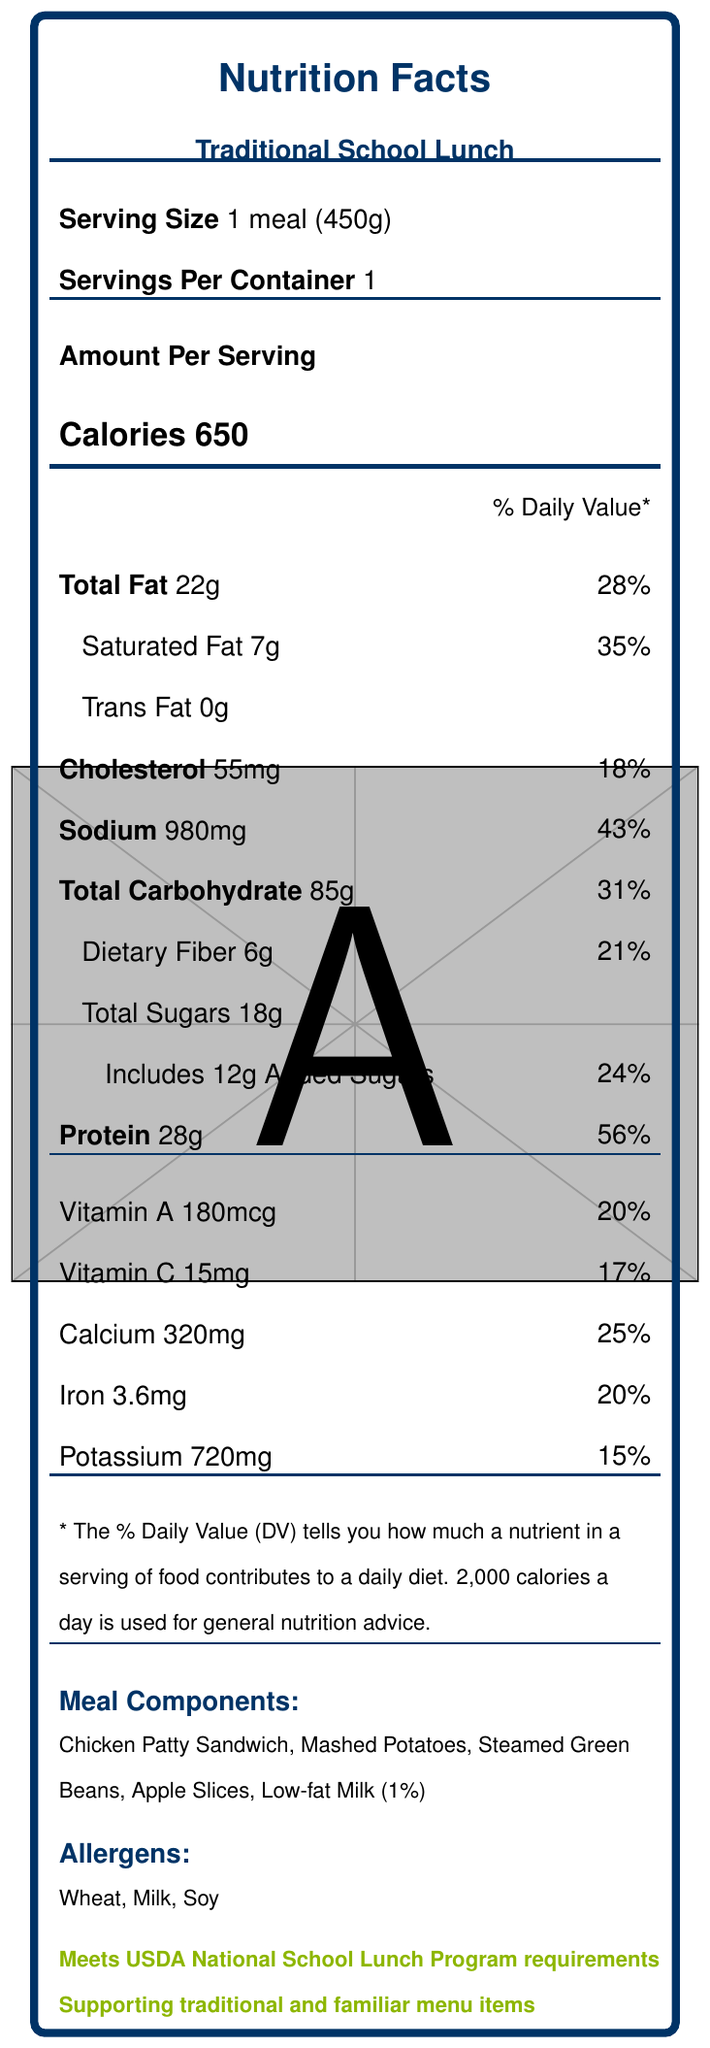What is the serving size for the school lunch meal? The serving size is explicitly stated as "1 meal (450g)" in the document.
Answer: 1 meal (450g) How many calories are in one serving of the meal? The number of calories per serving is listed as 650.
Answer: 650 What percentage of the daily value of saturated fat does the meal provide? The document states that the meal provides 7g of saturated fat, which is 35% of the daily value.
Answer: 35% How much sodium does the meal contain? The sodium content of the meal is specified as 980mg.
Answer: 980mg List the meal components included in the lunch. The meal components are listed in the document under "Meal Components".
Answer: Chicken Patty Sandwich, Mashed Potatoes, Steamed Green Beans, Apple Slices, Low-fat Milk (1%) What are the allergens present in the meal? The allergens are listed as "Wheat, Milk, Soy" in the "Allergens" section.
Answer: Wheat, Milk, Soy Which nutrient has the highest daily value percentage provided by the meal? A. Sodium B. Protein C. Vitamin A D. Calcium The meal provides 56% of the daily protein value, which is higher than the daily value percentage for sodium (43%), Vitamin A (20%), and calcium (25%).
Answer: B. Protein What is the primary source of protein in this meal? A. Apple Slices B. Low-fat Milk C. Chicken Patty Sandwich D. Steamed Green Beans The additional information section states that the source of protein is "Chicken patty made with whole muscle chicken".
Answer: C. Chicken Patty Sandwich Does the meal meet USDA National School Lunch Program requirements? The additional information section mentions that the meal "Meets USDA National School Lunch Program requirements".
Answer: Yes Summarize the main idea of the document. The document covers comprehensive nutritional data, meal components, allergens, and compliance notes for a traditional school lunch.
Answer: The document provides a detailed nutrition facts label for a standard school lunch meal consisting of a chicken patty sandwich, mashed potatoes, steamed green beans, apple slices, and low-fat milk. It includes information on the serving size, calorie content, nutrients, allergens, and compliance with USDA National School Lunch Program requirements. The meal aims to offer a balanced nutrition suitable for students. How much dietary fiber is provided by the meal? The dietary fiber content is listed as 6g in the nutrient section.
Answer: 6g Does the document provide details about the preparation methods of the meal items? The additional information section states that the majority of items are "prepared on-site in school kitchen facilities".
Answer: Yes What is the percentage of added sugars in the meal? The document states that the meal includes 12g of added sugars, which is 24% of the daily value.
Answer: 24% What is the cost per meal? The document does not provide any information regarding the cost per meal, so this cannot be determined from the available data.
Answer: Cannot be determined 